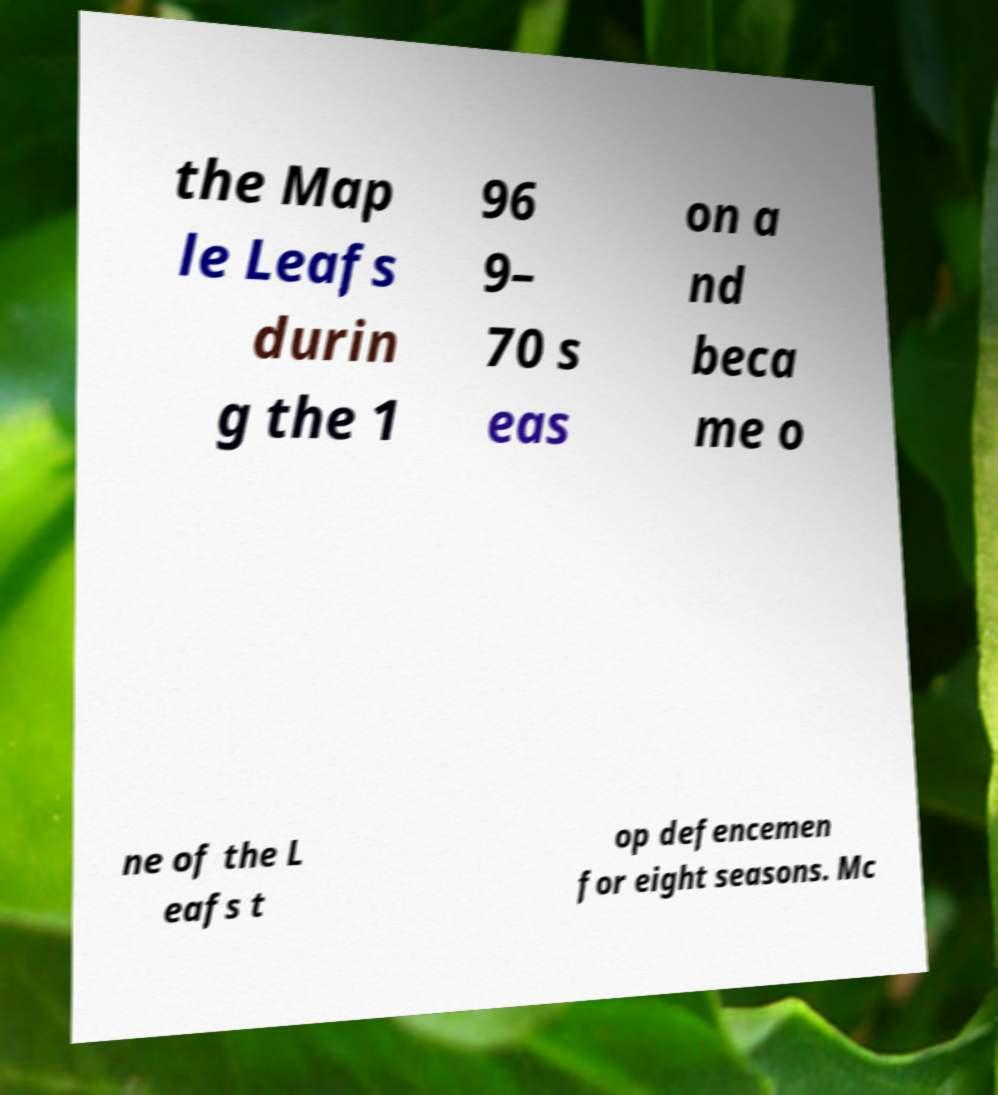Could you extract and type out the text from this image? the Map le Leafs durin g the 1 96 9– 70 s eas on a nd beca me o ne of the L eafs t op defencemen for eight seasons. Mc 